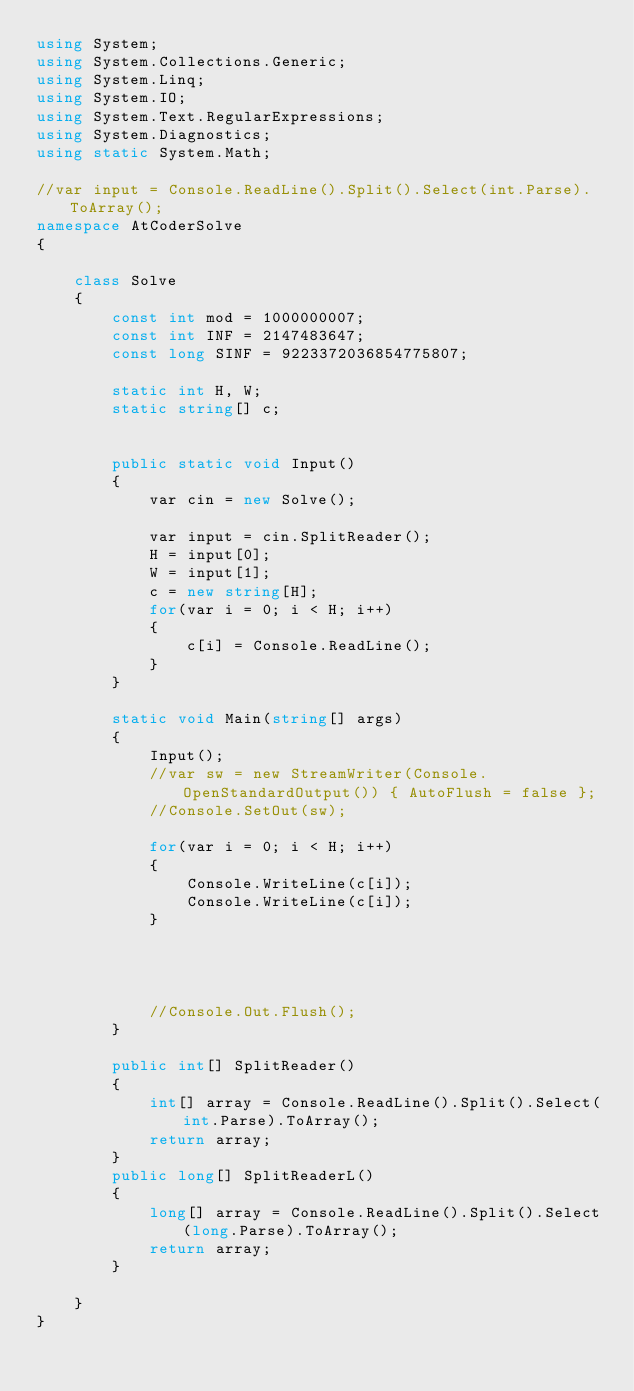Convert code to text. <code><loc_0><loc_0><loc_500><loc_500><_C#_>using System;
using System.Collections.Generic;
using System.Linq;
using System.IO;
using System.Text.RegularExpressions;
using System.Diagnostics;
using static System.Math;

//var input = Console.ReadLine().Split().Select(int.Parse).ToArray();
namespace AtCoderSolve
{

    class Solve
    {
        const int mod = 1000000007;
        const int INF = 2147483647;
        const long SINF = 9223372036854775807;

        static int H, W;
        static string[] c;


        public static void Input()
        {
            var cin = new Solve();

            var input = cin.SplitReader();
            H = input[0];
            W = input[1];
            c = new string[H];
            for(var i = 0; i < H; i++)
            {
                c[i] = Console.ReadLine();
            }
        }

        static void Main(string[] args)
        {
            Input();
            //var sw = new StreamWriter(Console.OpenStandardOutput()) { AutoFlush = false };
            //Console.SetOut(sw);
            
            for(var i = 0; i < H; i++)
            {
                Console.WriteLine(c[i]);
                Console.WriteLine(c[i]);
            }




            //Console.Out.Flush();
        }

        public int[] SplitReader()
        {
            int[] array = Console.ReadLine().Split().Select(int.Parse).ToArray();
            return array;
        }
        public long[] SplitReaderL()
        {
            long[] array = Console.ReadLine().Split().Select(long.Parse).ToArray();
            return array;
        }

    }
}

    

</code> 